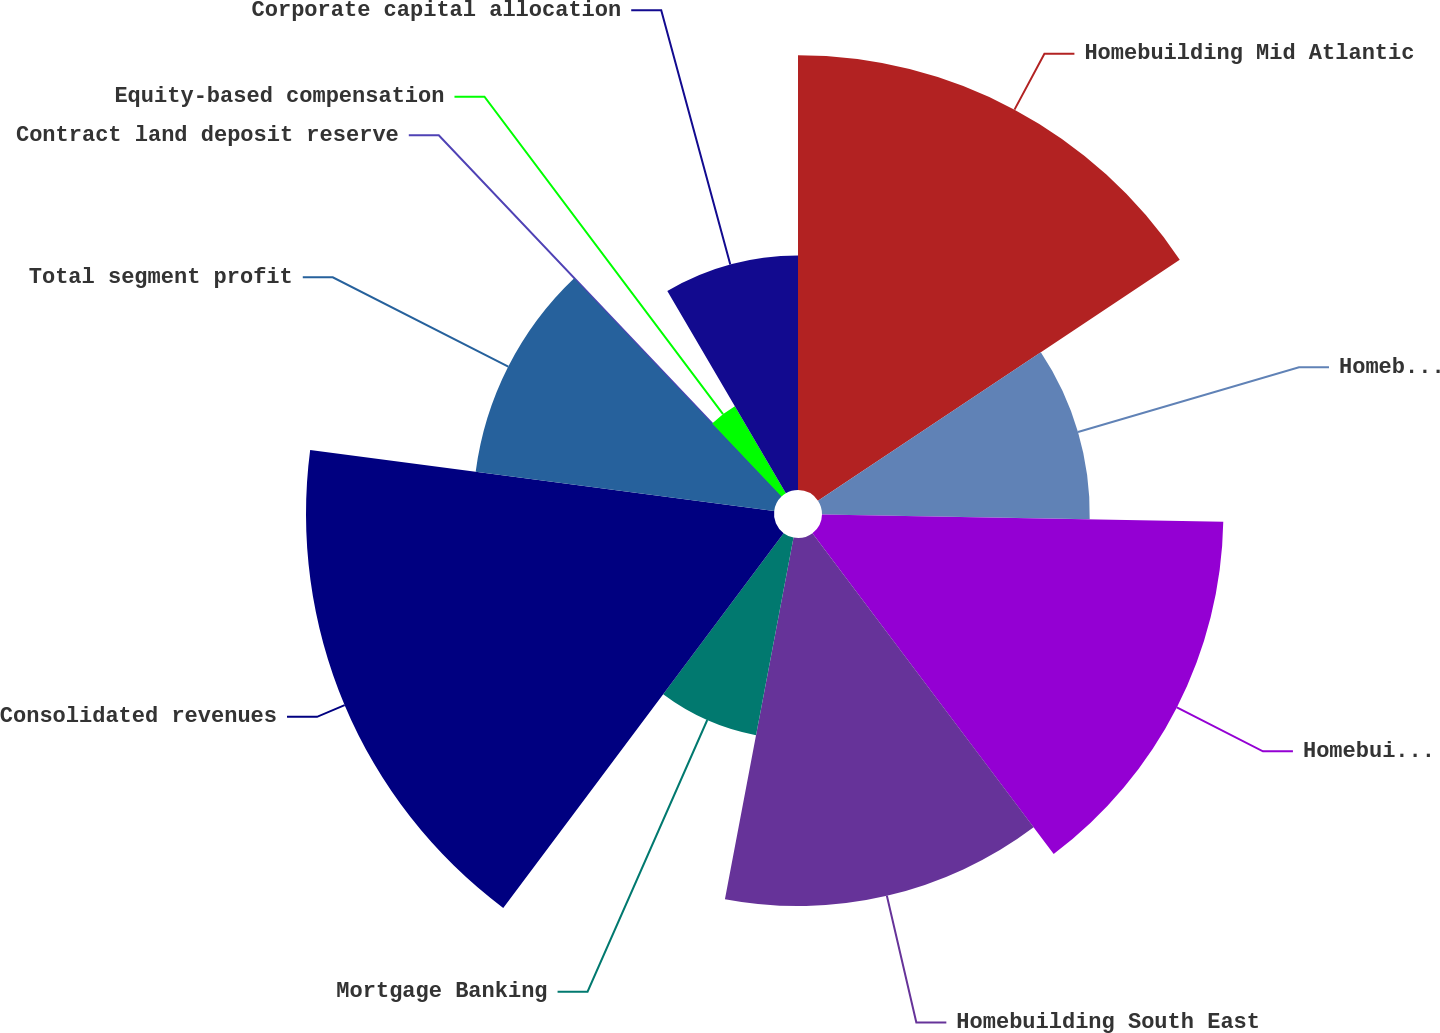Convert chart to OTSL. <chart><loc_0><loc_0><loc_500><loc_500><pie_chart><fcel>Homebuilding Mid Atlantic<fcel>Homebuilding North East<fcel>Homebuilding Mid East<fcel>Homebuilding South East<fcel>Mortgage Banking<fcel>Consolidated revenues<fcel>Total segment profit<fcel>Contract land deposit reserve<fcel>Equity-based compensation<fcel>Corporate capital allocation<nl><fcel>15.65%<fcel>9.64%<fcel>14.45%<fcel>13.25%<fcel>7.24%<fcel>16.85%<fcel>10.84%<fcel>0.02%<fcel>3.63%<fcel>8.44%<nl></chart> 